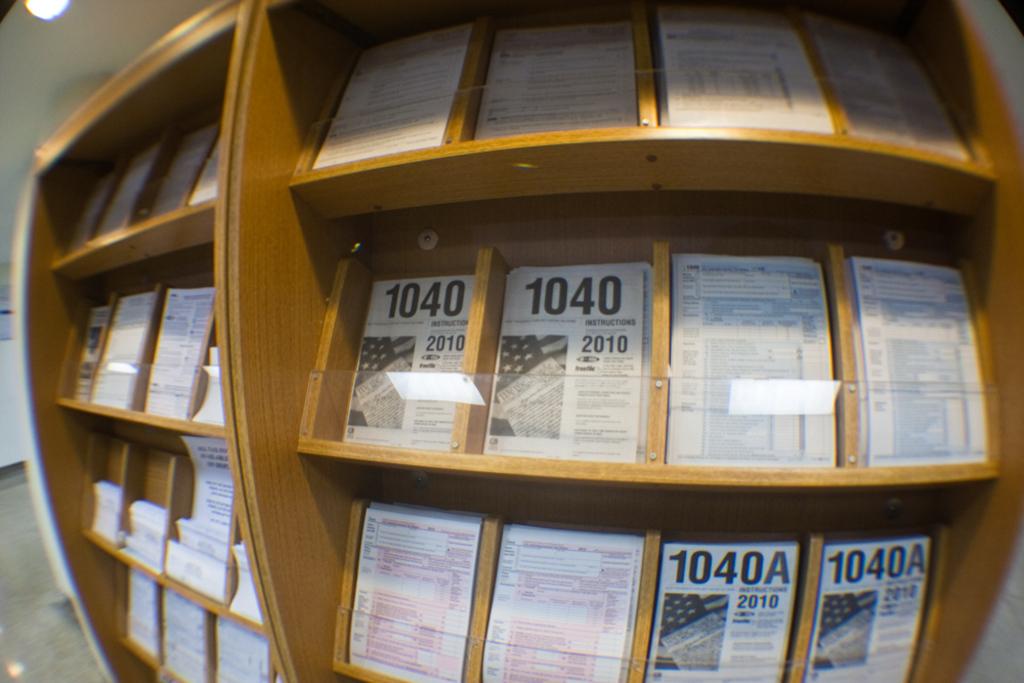What number is on the top of the page?
Your answer should be very brief. 1040. 